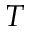Convert formula to latex. <formula><loc_0><loc_0><loc_500><loc_500>T</formula> 